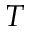Convert formula to latex. <formula><loc_0><loc_0><loc_500><loc_500>T</formula> 